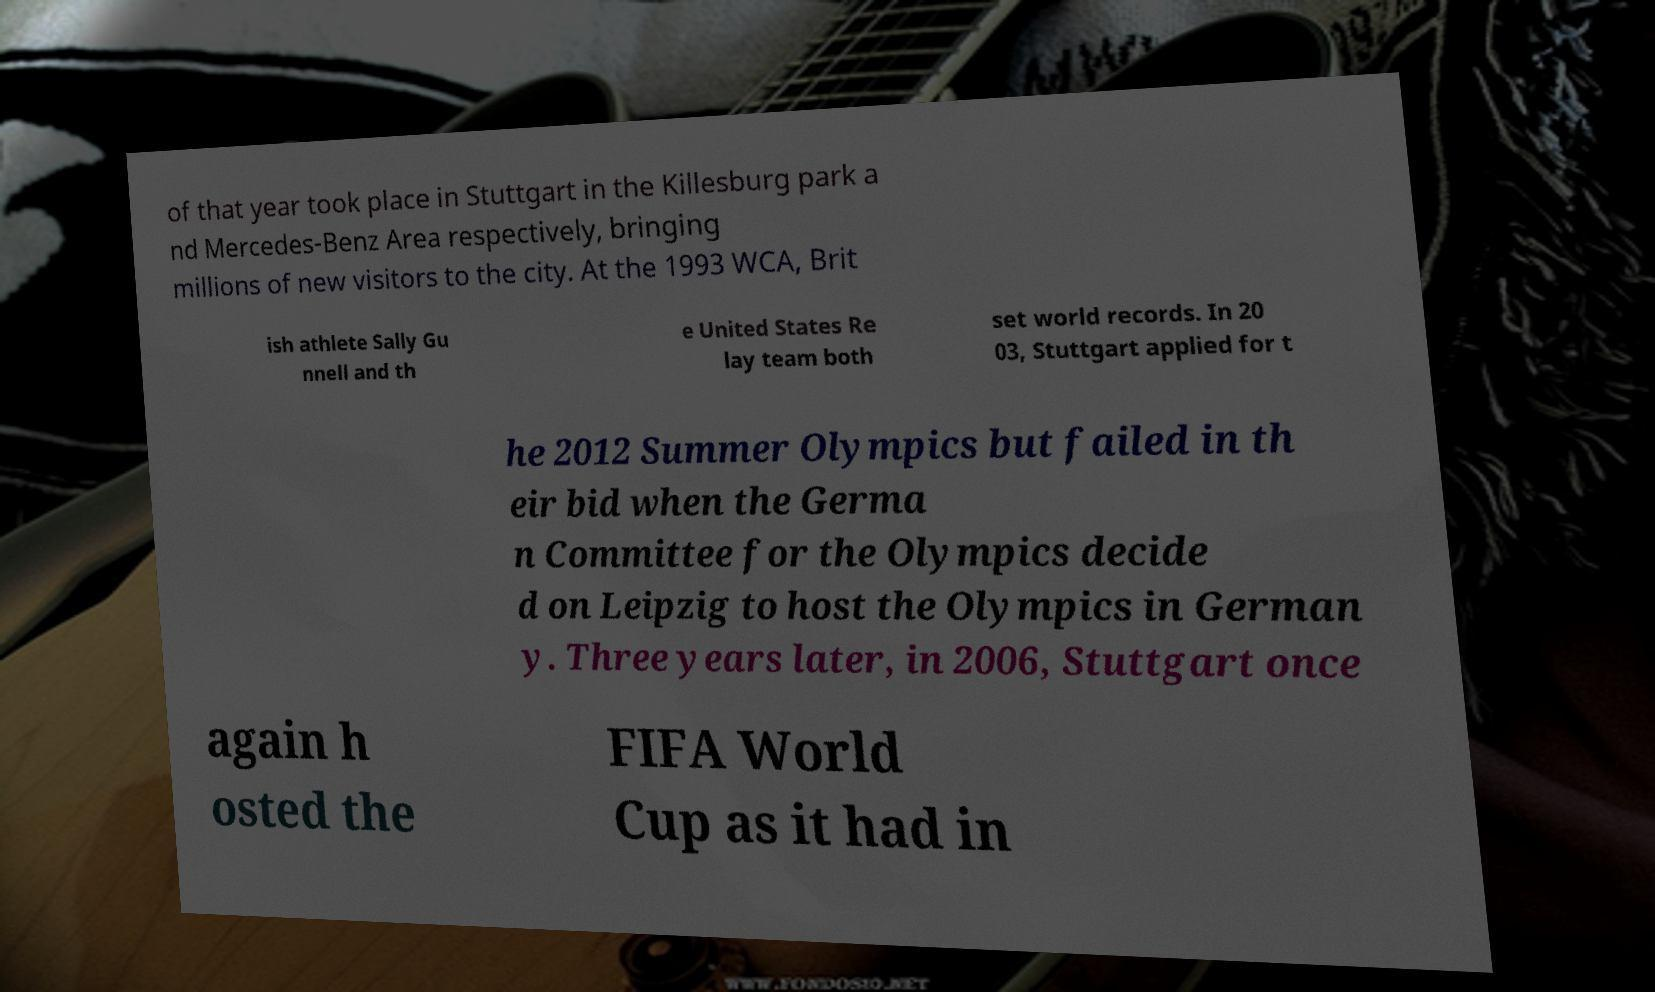Can you accurately transcribe the text from the provided image for me? of that year took place in Stuttgart in the Killesburg park a nd Mercedes-Benz Area respectively, bringing millions of new visitors to the city. At the 1993 WCA, Brit ish athlete Sally Gu nnell and th e United States Re lay team both set world records. In 20 03, Stuttgart applied for t he 2012 Summer Olympics but failed in th eir bid when the Germa n Committee for the Olympics decide d on Leipzig to host the Olympics in German y. Three years later, in 2006, Stuttgart once again h osted the FIFA World Cup as it had in 